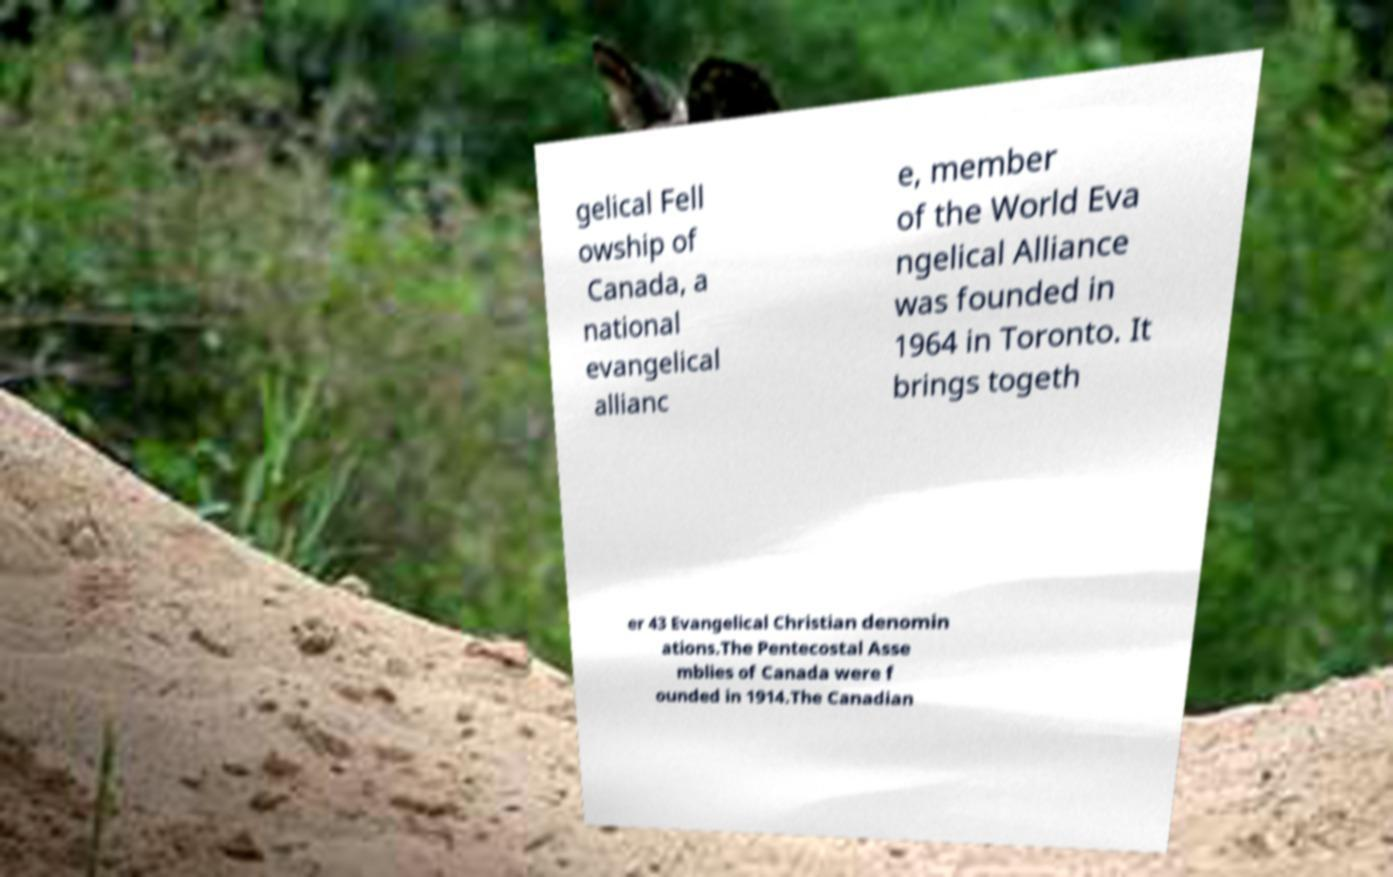Can you accurately transcribe the text from the provided image for me? gelical Fell owship of Canada, a national evangelical allianc e, member of the World Eva ngelical Alliance was founded in 1964 in Toronto. It brings togeth er 43 Evangelical Christian denomin ations.The Pentecostal Asse mblies of Canada were f ounded in 1914.The Canadian 